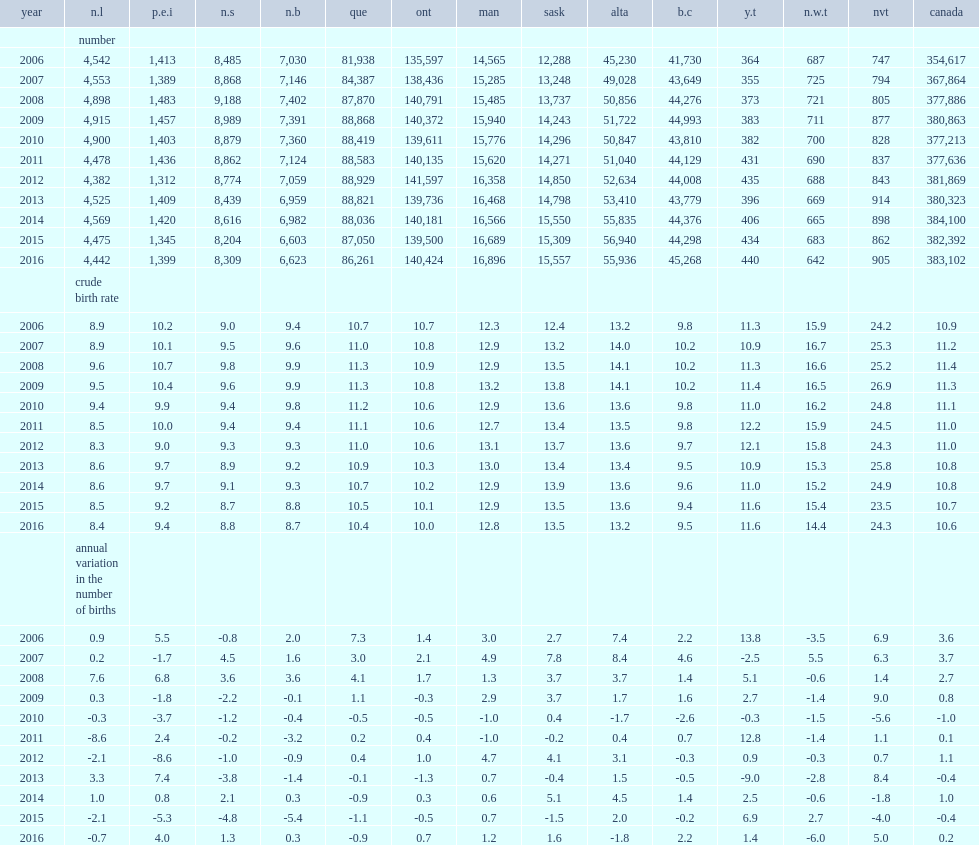How many births were there in 2012? 381869.0. How many births were there in 2013? 380323.0. How many births were there in 2014? 384100.0. How many births were there in 2015? 382392.0. How many births were there in 2016? 383102.0. 